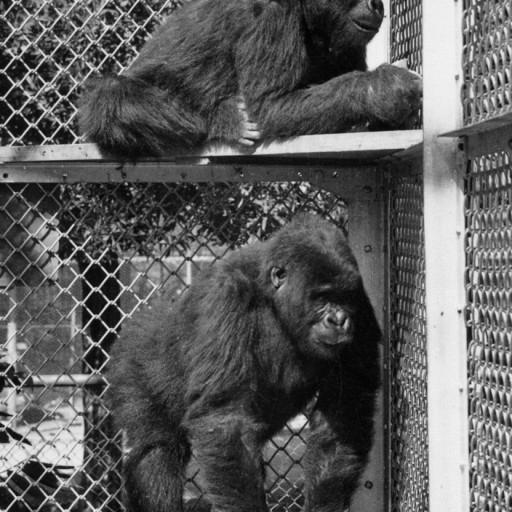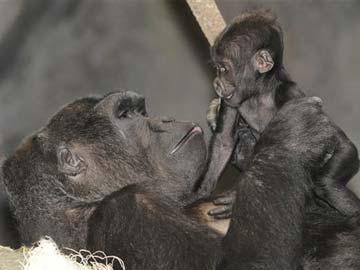The first image is the image on the left, the second image is the image on the right. For the images displayed, is the sentence "One image contains a group of three apes, and the other image features one adult gorilla sitting with a baby gorilla that is on the adult's chest and facing forward." factually correct? Answer yes or no. No. The first image is the image on the left, the second image is the image on the right. Assess this claim about the two images: "A female ape is holding a baby ape.". Correct or not? Answer yes or no. Yes. 